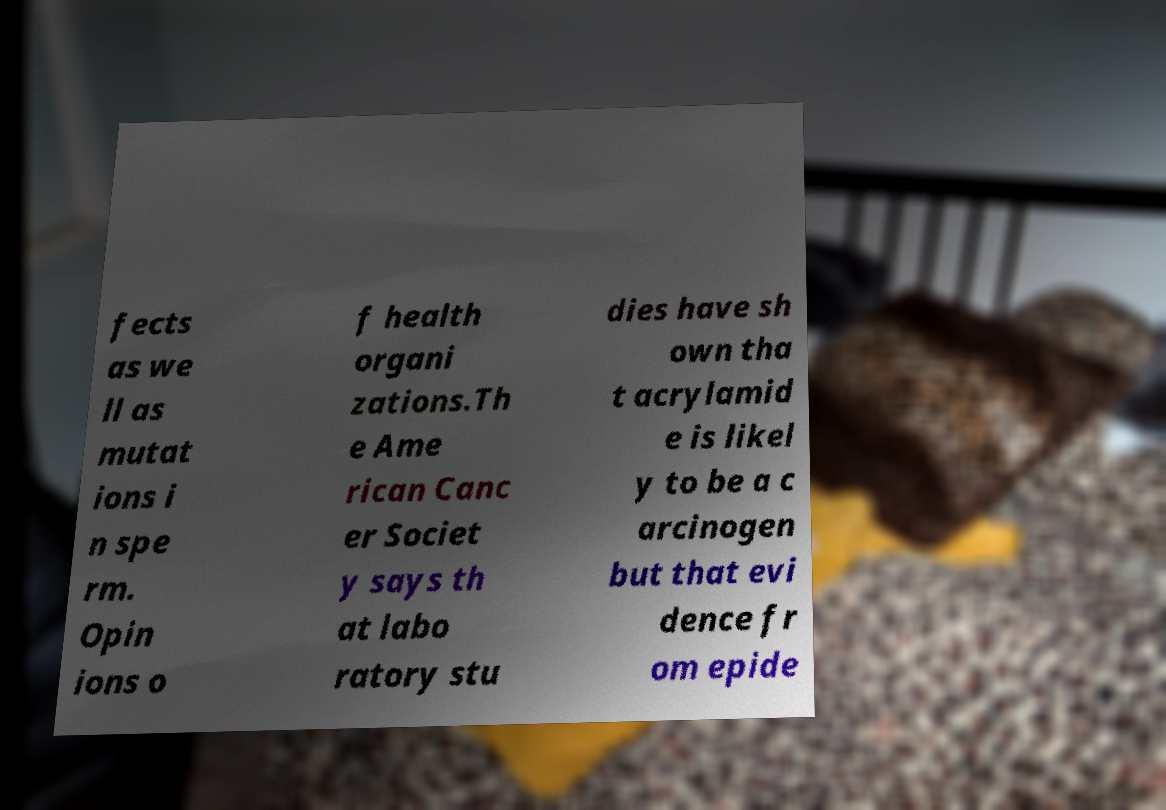Can you read and provide the text displayed in the image?This photo seems to have some interesting text. Can you extract and type it out for me? fects as we ll as mutat ions i n spe rm. Opin ions o f health organi zations.Th e Ame rican Canc er Societ y says th at labo ratory stu dies have sh own tha t acrylamid e is likel y to be a c arcinogen but that evi dence fr om epide 